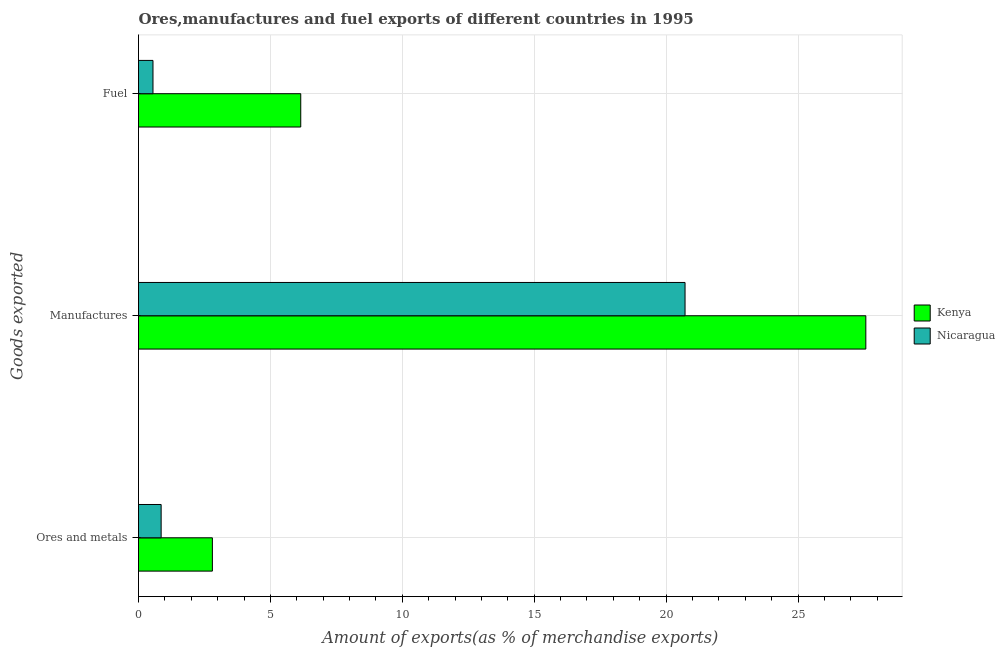How many different coloured bars are there?
Provide a short and direct response. 2. How many bars are there on the 1st tick from the bottom?
Your answer should be very brief. 2. What is the label of the 3rd group of bars from the top?
Ensure brevity in your answer.  Ores and metals. What is the percentage of manufactures exports in Kenya?
Provide a short and direct response. 27.57. Across all countries, what is the maximum percentage of ores and metals exports?
Make the answer very short. 2.8. Across all countries, what is the minimum percentage of manufactures exports?
Offer a terse response. 20.72. In which country was the percentage of manufactures exports maximum?
Provide a succinct answer. Kenya. In which country was the percentage of fuel exports minimum?
Make the answer very short. Nicaragua. What is the total percentage of ores and metals exports in the graph?
Offer a terse response. 3.66. What is the difference between the percentage of ores and metals exports in Kenya and that in Nicaragua?
Your response must be concise. 1.94. What is the difference between the percentage of ores and metals exports in Kenya and the percentage of manufactures exports in Nicaragua?
Keep it short and to the point. -17.92. What is the average percentage of ores and metals exports per country?
Your answer should be very brief. 1.83. What is the difference between the percentage of ores and metals exports and percentage of fuel exports in Nicaragua?
Provide a succinct answer. 0.31. What is the ratio of the percentage of ores and metals exports in Kenya to that in Nicaragua?
Provide a succinct answer. 3.26. Is the percentage of ores and metals exports in Nicaragua less than that in Kenya?
Your response must be concise. Yes. What is the difference between the highest and the second highest percentage of manufactures exports?
Provide a short and direct response. 6.85. What is the difference between the highest and the lowest percentage of ores and metals exports?
Make the answer very short. 1.94. Is the sum of the percentage of manufactures exports in Nicaragua and Kenya greater than the maximum percentage of fuel exports across all countries?
Ensure brevity in your answer.  Yes. What does the 1st bar from the top in Ores and metals represents?
Ensure brevity in your answer.  Nicaragua. What does the 2nd bar from the bottom in Fuel represents?
Your response must be concise. Nicaragua. Is it the case that in every country, the sum of the percentage of ores and metals exports and percentage of manufactures exports is greater than the percentage of fuel exports?
Ensure brevity in your answer.  Yes. Are the values on the major ticks of X-axis written in scientific E-notation?
Your response must be concise. No. Does the graph contain any zero values?
Keep it short and to the point. No. How many legend labels are there?
Make the answer very short. 2. How are the legend labels stacked?
Offer a terse response. Vertical. What is the title of the graph?
Ensure brevity in your answer.  Ores,manufactures and fuel exports of different countries in 1995. What is the label or title of the X-axis?
Make the answer very short. Amount of exports(as % of merchandise exports). What is the label or title of the Y-axis?
Give a very brief answer. Goods exported. What is the Amount of exports(as % of merchandise exports) in Kenya in Ores and metals?
Provide a short and direct response. 2.8. What is the Amount of exports(as % of merchandise exports) of Nicaragua in Ores and metals?
Your answer should be very brief. 0.86. What is the Amount of exports(as % of merchandise exports) in Kenya in Manufactures?
Your answer should be very brief. 27.57. What is the Amount of exports(as % of merchandise exports) in Nicaragua in Manufactures?
Make the answer very short. 20.72. What is the Amount of exports(as % of merchandise exports) in Kenya in Fuel?
Keep it short and to the point. 6.15. What is the Amount of exports(as % of merchandise exports) of Nicaragua in Fuel?
Make the answer very short. 0.55. Across all Goods exported, what is the maximum Amount of exports(as % of merchandise exports) of Kenya?
Provide a short and direct response. 27.57. Across all Goods exported, what is the maximum Amount of exports(as % of merchandise exports) of Nicaragua?
Keep it short and to the point. 20.72. Across all Goods exported, what is the minimum Amount of exports(as % of merchandise exports) of Kenya?
Offer a very short reply. 2.8. Across all Goods exported, what is the minimum Amount of exports(as % of merchandise exports) of Nicaragua?
Offer a terse response. 0.55. What is the total Amount of exports(as % of merchandise exports) in Kenya in the graph?
Keep it short and to the point. 36.52. What is the total Amount of exports(as % of merchandise exports) of Nicaragua in the graph?
Offer a very short reply. 22.13. What is the difference between the Amount of exports(as % of merchandise exports) in Kenya in Ores and metals and that in Manufactures?
Offer a terse response. -24.77. What is the difference between the Amount of exports(as % of merchandise exports) in Nicaragua in Ores and metals and that in Manufactures?
Offer a terse response. -19.86. What is the difference between the Amount of exports(as % of merchandise exports) in Kenya in Ores and metals and that in Fuel?
Keep it short and to the point. -3.35. What is the difference between the Amount of exports(as % of merchandise exports) of Nicaragua in Ores and metals and that in Fuel?
Keep it short and to the point. 0.31. What is the difference between the Amount of exports(as % of merchandise exports) in Kenya in Manufactures and that in Fuel?
Provide a succinct answer. 21.42. What is the difference between the Amount of exports(as % of merchandise exports) of Nicaragua in Manufactures and that in Fuel?
Offer a terse response. 20.17. What is the difference between the Amount of exports(as % of merchandise exports) in Kenya in Ores and metals and the Amount of exports(as % of merchandise exports) in Nicaragua in Manufactures?
Your response must be concise. -17.92. What is the difference between the Amount of exports(as % of merchandise exports) of Kenya in Ores and metals and the Amount of exports(as % of merchandise exports) of Nicaragua in Fuel?
Provide a succinct answer. 2.25. What is the difference between the Amount of exports(as % of merchandise exports) of Kenya in Manufactures and the Amount of exports(as % of merchandise exports) of Nicaragua in Fuel?
Make the answer very short. 27.02. What is the average Amount of exports(as % of merchandise exports) of Kenya per Goods exported?
Give a very brief answer. 12.17. What is the average Amount of exports(as % of merchandise exports) in Nicaragua per Goods exported?
Make the answer very short. 7.38. What is the difference between the Amount of exports(as % of merchandise exports) in Kenya and Amount of exports(as % of merchandise exports) in Nicaragua in Ores and metals?
Provide a short and direct response. 1.94. What is the difference between the Amount of exports(as % of merchandise exports) in Kenya and Amount of exports(as % of merchandise exports) in Nicaragua in Manufactures?
Provide a succinct answer. 6.85. What is the difference between the Amount of exports(as % of merchandise exports) of Kenya and Amount of exports(as % of merchandise exports) of Nicaragua in Fuel?
Make the answer very short. 5.6. What is the ratio of the Amount of exports(as % of merchandise exports) in Kenya in Ores and metals to that in Manufactures?
Your response must be concise. 0.1. What is the ratio of the Amount of exports(as % of merchandise exports) of Nicaragua in Ores and metals to that in Manufactures?
Provide a succinct answer. 0.04. What is the ratio of the Amount of exports(as % of merchandise exports) of Kenya in Ores and metals to that in Fuel?
Your answer should be compact. 0.46. What is the ratio of the Amount of exports(as % of merchandise exports) in Nicaragua in Ores and metals to that in Fuel?
Your answer should be compact. 1.56. What is the ratio of the Amount of exports(as % of merchandise exports) in Kenya in Manufactures to that in Fuel?
Your answer should be very brief. 4.48. What is the ratio of the Amount of exports(as % of merchandise exports) in Nicaragua in Manufactures to that in Fuel?
Provide a short and direct response. 37.76. What is the difference between the highest and the second highest Amount of exports(as % of merchandise exports) in Kenya?
Keep it short and to the point. 21.42. What is the difference between the highest and the second highest Amount of exports(as % of merchandise exports) in Nicaragua?
Your answer should be compact. 19.86. What is the difference between the highest and the lowest Amount of exports(as % of merchandise exports) in Kenya?
Offer a terse response. 24.77. What is the difference between the highest and the lowest Amount of exports(as % of merchandise exports) in Nicaragua?
Offer a terse response. 20.17. 